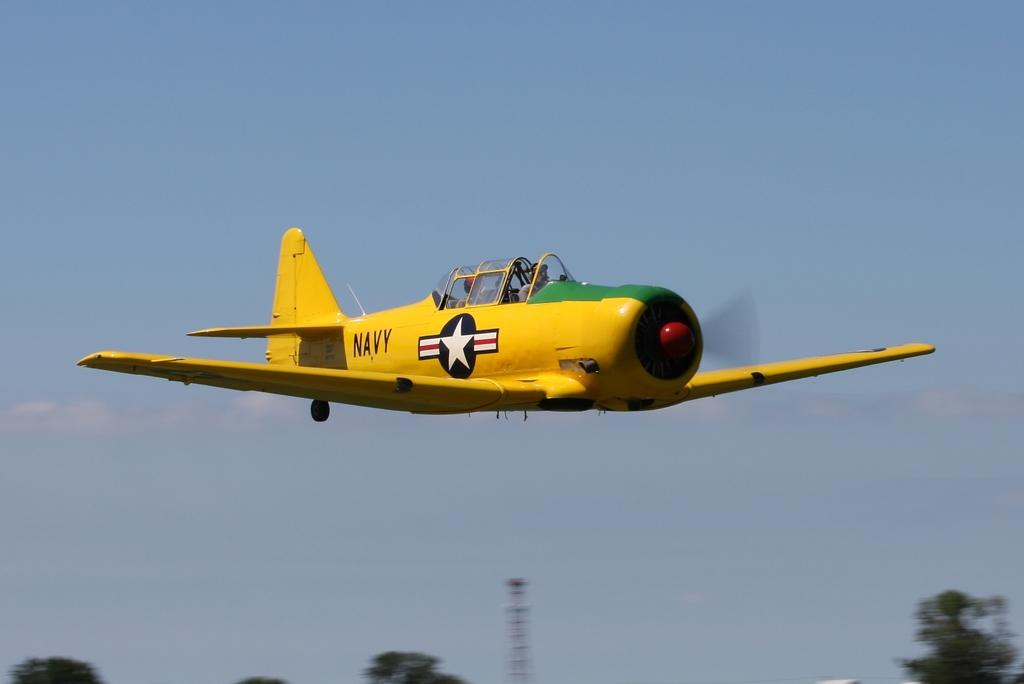Provide a one-sentence caption for the provided image. A yellow and green Navy open cockpit plane flying low. 